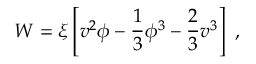<formula> <loc_0><loc_0><loc_500><loc_500>W = \xi \left [ v ^ { 2 } \phi - { \frac { 1 } { 3 } } \phi ^ { 3 } - { \frac { 2 } { 3 } } v ^ { 3 } \right ] ,</formula> 